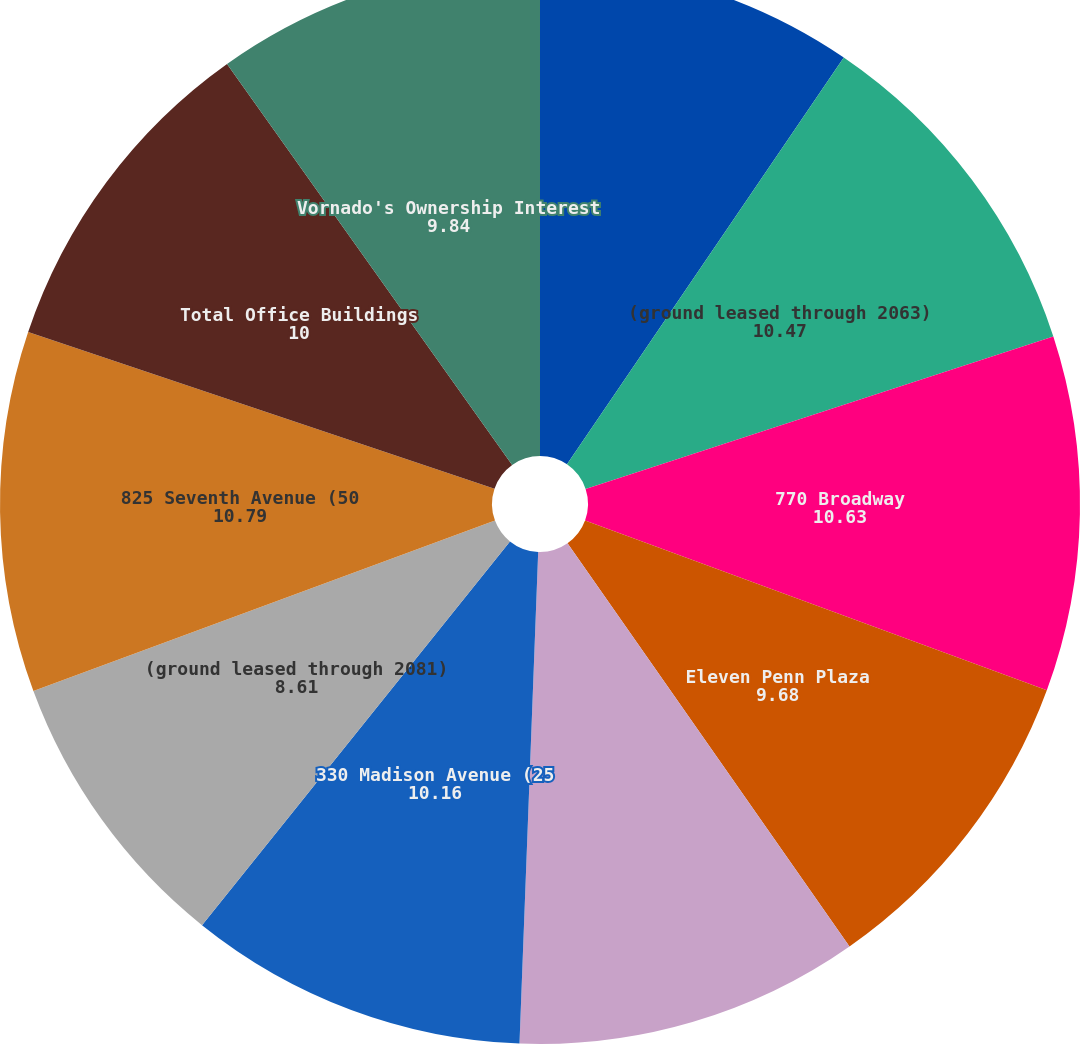Convert chart to OTSL. <chart><loc_0><loc_0><loc_500><loc_500><pie_chart><fcel>Two Penn Plaza<fcel>(ground leased through 2063)<fcel>770 Broadway<fcel>Eleven Penn Plaza<fcel>(ground leased through 2067)<fcel>330 Madison Avenue (25<fcel>(ground leased through 2081)<fcel>825 Seventh Avenue (50<fcel>Total Office Buildings<fcel>Vornado's Ownership Interest<nl><fcel>9.51%<fcel>10.47%<fcel>10.63%<fcel>9.68%<fcel>10.32%<fcel>10.16%<fcel>8.61%<fcel>10.79%<fcel>10.0%<fcel>9.84%<nl></chart> 